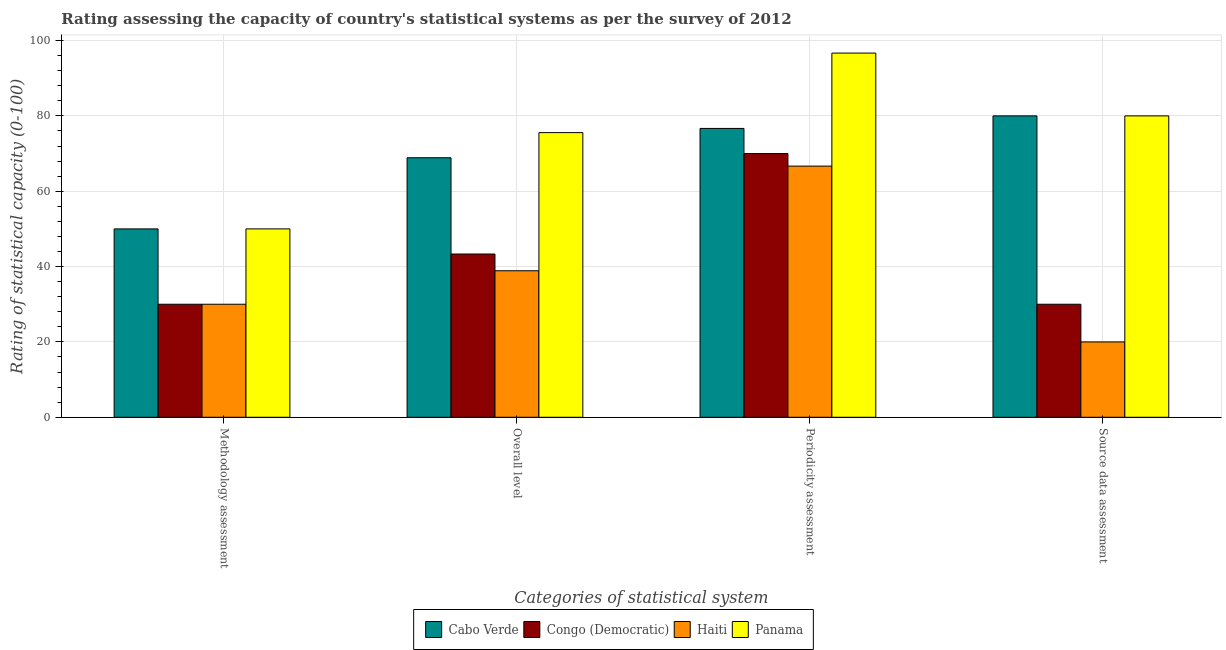How many different coloured bars are there?
Your answer should be compact. 4. How many bars are there on the 4th tick from the left?
Ensure brevity in your answer.  4. What is the label of the 1st group of bars from the left?
Make the answer very short. Methodology assessment. What is the methodology assessment rating in Cabo Verde?
Your answer should be compact. 50. Across all countries, what is the maximum periodicity assessment rating?
Provide a succinct answer. 96.67. Across all countries, what is the minimum periodicity assessment rating?
Keep it short and to the point. 66.67. In which country was the methodology assessment rating maximum?
Make the answer very short. Cabo Verde. In which country was the methodology assessment rating minimum?
Offer a very short reply. Congo (Democratic). What is the total source data assessment rating in the graph?
Keep it short and to the point. 210. What is the difference between the methodology assessment rating in Haiti and that in Congo (Democratic)?
Make the answer very short. 0. What is the difference between the source data assessment rating in Haiti and the periodicity assessment rating in Cabo Verde?
Make the answer very short. -56.67. What is the average overall level rating per country?
Offer a very short reply. 56.67. What is the difference between the source data assessment rating and overall level rating in Congo (Democratic)?
Offer a terse response. -13.33. What is the difference between the highest and the second highest periodicity assessment rating?
Give a very brief answer. 20. What is the difference between the highest and the lowest source data assessment rating?
Provide a succinct answer. 60. Is the sum of the periodicity assessment rating in Congo (Democratic) and Panama greater than the maximum overall level rating across all countries?
Your response must be concise. Yes. What does the 3rd bar from the left in Overall level represents?
Your answer should be compact. Haiti. What does the 3rd bar from the right in Methodology assessment represents?
Make the answer very short. Congo (Democratic). How many bars are there?
Provide a succinct answer. 16. What is the difference between two consecutive major ticks on the Y-axis?
Make the answer very short. 20. Are the values on the major ticks of Y-axis written in scientific E-notation?
Offer a very short reply. No. Where does the legend appear in the graph?
Provide a short and direct response. Bottom center. How are the legend labels stacked?
Keep it short and to the point. Horizontal. What is the title of the graph?
Your answer should be very brief. Rating assessing the capacity of country's statistical systems as per the survey of 2012 . What is the label or title of the X-axis?
Give a very brief answer. Categories of statistical system. What is the label or title of the Y-axis?
Offer a very short reply. Rating of statistical capacity (0-100). What is the Rating of statistical capacity (0-100) in Congo (Democratic) in Methodology assessment?
Your answer should be compact. 30. What is the Rating of statistical capacity (0-100) of Panama in Methodology assessment?
Your response must be concise. 50. What is the Rating of statistical capacity (0-100) in Cabo Verde in Overall level?
Give a very brief answer. 68.89. What is the Rating of statistical capacity (0-100) in Congo (Democratic) in Overall level?
Your answer should be compact. 43.33. What is the Rating of statistical capacity (0-100) of Haiti in Overall level?
Give a very brief answer. 38.89. What is the Rating of statistical capacity (0-100) of Panama in Overall level?
Ensure brevity in your answer.  75.56. What is the Rating of statistical capacity (0-100) of Cabo Verde in Periodicity assessment?
Your answer should be compact. 76.67. What is the Rating of statistical capacity (0-100) of Haiti in Periodicity assessment?
Make the answer very short. 66.67. What is the Rating of statistical capacity (0-100) in Panama in Periodicity assessment?
Offer a very short reply. 96.67. Across all Categories of statistical system, what is the maximum Rating of statistical capacity (0-100) in Cabo Verde?
Make the answer very short. 80. Across all Categories of statistical system, what is the maximum Rating of statistical capacity (0-100) in Congo (Democratic)?
Ensure brevity in your answer.  70. Across all Categories of statistical system, what is the maximum Rating of statistical capacity (0-100) in Haiti?
Provide a short and direct response. 66.67. Across all Categories of statistical system, what is the maximum Rating of statistical capacity (0-100) in Panama?
Your answer should be compact. 96.67. Across all Categories of statistical system, what is the minimum Rating of statistical capacity (0-100) of Panama?
Ensure brevity in your answer.  50. What is the total Rating of statistical capacity (0-100) in Cabo Verde in the graph?
Offer a very short reply. 275.56. What is the total Rating of statistical capacity (0-100) in Congo (Democratic) in the graph?
Your response must be concise. 173.33. What is the total Rating of statistical capacity (0-100) in Haiti in the graph?
Provide a short and direct response. 155.56. What is the total Rating of statistical capacity (0-100) in Panama in the graph?
Ensure brevity in your answer.  302.22. What is the difference between the Rating of statistical capacity (0-100) in Cabo Verde in Methodology assessment and that in Overall level?
Make the answer very short. -18.89. What is the difference between the Rating of statistical capacity (0-100) of Congo (Democratic) in Methodology assessment and that in Overall level?
Provide a short and direct response. -13.33. What is the difference between the Rating of statistical capacity (0-100) in Haiti in Methodology assessment and that in Overall level?
Your answer should be very brief. -8.89. What is the difference between the Rating of statistical capacity (0-100) in Panama in Methodology assessment and that in Overall level?
Offer a terse response. -25.56. What is the difference between the Rating of statistical capacity (0-100) of Cabo Verde in Methodology assessment and that in Periodicity assessment?
Offer a very short reply. -26.67. What is the difference between the Rating of statistical capacity (0-100) of Haiti in Methodology assessment and that in Periodicity assessment?
Your answer should be very brief. -36.67. What is the difference between the Rating of statistical capacity (0-100) of Panama in Methodology assessment and that in Periodicity assessment?
Your response must be concise. -46.67. What is the difference between the Rating of statistical capacity (0-100) of Cabo Verde in Methodology assessment and that in Source data assessment?
Offer a terse response. -30. What is the difference between the Rating of statistical capacity (0-100) in Congo (Democratic) in Methodology assessment and that in Source data assessment?
Your answer should be compact. 0. What is the difference between the Rating of statistical capacity (0-100) in Cabo Verde in Overall level and that in Periodicity assessment?
Offer a terse response. -7.78. What is the difference between the Rating of statistical capacity (0-100) of Congo (Democratic) in Overall level and that in Periodicity assessment?
Make the answer very short. -26.67. What is the difference between the Rating of statistical capacity (0-100) in Haiti in Overall level and that in Periodicity assessment?
Keep it short and to the point. -27.78. What is the difference between the Rating of statistical capacity (0-100) in Panama in Overall level and that in Periodicity assessment?
Offer a terse response. -21.11. What is the difference between the Rating of statistical capacity (0-100) of Cabo Verde in Overall level and that in Source data assessment?
Give a very brief answer. -11.11. What is the difference between the Rating of statistical capacity (0-100) in Congo (Democratic) in Overall level and that in Source data assessment?
Make the answer very short. 13.33. What is the difference between the Rating of statistical capacity (0-100) in Haiti in Overall level and that in Source data assessment?
Your answer should be very brief. 18.89. What is the difference between the Rating of statistical capacity (0-100) in Panama in Overall level and that in Source data assessment?
Provide a succinct answer. -4.44. What is the difference between the Rating of statistical capacity (0-100) of Cabo Verde in Periodicity assessment and that in Source data assessment?
Make the answer very short. -3.33. What is the difference between the Rating of statistical capacity (0-100) of Haiti in Periodicity assessment and that in Source data assessment?
Provide a short and direct response. 46.67. What is the difference between the Rating of statistical capacity (0-100) in Panama in Periodicity assessment and that in Source data assessment?
Offer a very short reply. 16.67. What is the difference between the Rating of statistical capacity (0-100) in Cabo Verde in Methodology assessment and the Rating of statistical capacity (0-100) in Haiti in Overall level?
Ensure brevity in your answer.  11.11. What is the difference between the Rating of statistical capacity (0-100) of Cabo Verde in Methodology assessment and the Rating of statistical capacity (0-100) of Panama in Overall level?
Offer a very short reply. -25.56. What is the difference between the Rating of statistical capacity (0-100) of Congo (Democratic) in Methodology assessment and the Rating of statistical capacity (0-100) of Haiti in Overall level?
Offer a terse response. -8.89. What is the difference between the Rating of statistical capacity (0-100) in Congo (Democratic) in Methodology assessment and the Rating of statistical capacity (0-100) in Panama in Overall level?
Provide a succinct answer. -45.56. What is the difference between the Rating of statistical capacity (0-100) in Haiti in Methodology assessment and the Rating of statistical capacity (0-100) in Panama in Overall level?
Offer a terse response. -45.56. What is the difference between the Rating of statistical capacity (0-100) in Cabo Verde in Methodology assessment and the Rating of statistical capacity (0-100) in Haiti in Periodicity assessment?
Your answer should be compact. -16.67. What is the difference between the Rating of statistical capacity (0-100) in Cabo Verde in Methodology assessment and the Rating of statistical capacity (0-100) in Panama in Periodicity assessment?
Keep it short and to the point. -46.67. What is the difference between the Rating of statistical capacity (0-100) of Congo (Democratic) in Methodology assessment and the Rating of statistical capacity (0-100) of Haiti in Periodicity assessment?
Keep it short and to the point. -36.67. What is the difference between the Rating of statistical capacity (0-100) of Congo (Democratic) in Methodology assessment and the Rating of statistical capacity (0-100) of Panama in Periodicity assessment?
Provide a short and direct response. -66.67. What is the difference between the Rating of statistical capacity (0-100) in Haiti in Methodology assessment and the Rating of statistical capacity (0-100) in Panama in Periodicity assessment?
Ensure brevity in your answer.  -66.67. What is the difference between the Rating of statistical capacity (0-100) of Cabo Verde in Methodology assessment and the Rating of statistical capacity (0-100) of Congo (Democratic) in Source data assessment?
Keep it short and to the point. 20. What is the difference between the Rating of statistical capacity (0-100) of Cabo Verde in Overall level and the Rating of statistical capacity (0-100) of Congo (Democratic) in Periodicity assessment?
Offer a terse response. -1.11. What is the difference between the Rating of statistical capacity (0-100) of Cabo Verde in Overall level and the Rating of statistical capacity (0-100) of Haiti in Periodicity assessment?
Ensure brevity in your answer.  2.22. What is the difference between the Rating of statistical capacity (0-100) of Cabo Verde in Overall level and the Rating of statistical capacity (0-100) of Panama in Periodicity assessment?
Give a very brief answer. -27.78. What is the difference between the Rating of statistical capacity (0-100) in Congo (Democratic) in Overall level and the Rating of statistical capacity (0-100) in Haiti in Periodicity assessment?
Give a very brief answer. -23.33. What is the difference between the Rating of statistical capacity (0-100) of Congo (Democratic) in Overall level and the Rating of statistical capacity (0-100) of Panama in Periodicity assessment?
Make the answer very short. -53.33. What is the difference between the Rating of statistical capacity (0-100) in Haiti in Overall level and the Rating of statistical capacity (0-100) in Panama in Periodicity assessment?
Keep it short and to the point. -57.78. What is the difference between the Rating of statistical capacity (0-100) in Cabo Verde in Overall level and the Rating of statistical capacity (0-100) in Congo (Democratic) in Source data assessment?
Your response must be concise. 38.89. What is the difference between the Rating of statistical capacity (0-100) in Cabo Verde in Overall level and the Rating of statistical capacity (0-100) in Haiti in Source data assessment?
Your answer should be very brief. 48.89. What is the difference between the Rating of statistical capacity (0-100) in Cabo Verde in Overall level and the Rating of statistical capacity (0-100) in Panama in Source data assessment?
Give a very brief answer. -11.11. What is the difference between the Rating of statistical capacity (0-100) of Congo (Democratic) in Overall level and the Rating of statistical capacity (0-100) of Haiti in Source data assessment?
Offer a terse response. 23.33. What is the difference between the Rating of statistical capacity (0-100) of Congo (Democratic) in Overall level and the Rating of statistical capacity (0-100) of Panama in Source data assessment?
Your answer should be very brief. -36.67. What is the difference between the Rating of statistical capacity (0-100) of Haiti in Overall level and the Rating of statistical capacity (0-100) of Panama in Source data assessment?
Your answer should be very brief. -41.11. What is the difference between the Rating of statistical capacity (0-100) in Cabo Verde in Periodicity assessment and the Rating of statistical capacity (0-100) in Congo (Democratic) in Source data assessment?
Your answer should be very brief. 46.67. What is the difference between the Rating of statistical capacity (0-100) in Cabo Verde in Periodicity assessment and the Rating of statistical capacity (0-100) in Haiti in Source data assessment?
Ensure brevity in your answer.  56.67. What is the difference between the Rating of statistical capacity (0-100) in Congo (Democratic) in Periodicity assessment and the Rating of statistical capacity (0-100) in Haiti in Source data assessment?
Your response must be concise. 50. What is the difference between the Rating of statistical capacity (0-100) in Haiti in Periodicity assessment and the Rating of statistical capacity (0-100) in Panama in Source data assessment?
Give a very brief answer. -13.33. What is the average Rating of statistical capacity (0-100) in Cabo Verde per Categories of statistical system?
Offer a terse response. 68.89. What is the average Rating of statistical capacity (0-100) of Congo (Democratic) per Categories of statistical system?
Provide a succinct answer. 43.33. What is the average Rating of statistical capacity (0-100) of Haiti per Categories of statistical system?
Offer a very short reply. 38.89. What is the average Rating of statistical capacity (0-100) in Panama per Categories of statistical system?
Give a very brief answer. 75.56. What is the difference between the Rating of statistical capacity (0-100) in Cabo Verde and Rating of statistical capacity (0-100) in Panama in Methodology assessment?
Your answer should be very brief. 0. What is the difference between the Rating of statistical capacity (0-100) of Congo (Democratic) and Rating of statistical capacity (0-100) of Haiti in Methodology assessment?
Provide a succinct answer. 0. What is the difference between the Rating of statistical capacity (0-100) in Congo (Democratic) and Rating of statistical capacity (0-100) in Panama in Methodology assessment?
Your answer should be very brief. -20. What is the difference between the Rating of statistical capacity (0-100) in Haiti and Rating of statistical capacity (0-100) in Panama in Methodology assessment?
Offer a very short reply. -20. What is the difference between the Rating of statistical capacity (0-100) in Cabo Verde and Rating of statistical capacity (0-100) in Congo (Democratic) in Overall level?
Keep it short and to the point. 25.56. What is the difference between the Rating of statistical capacity (0-100) in Cabo Verde and Rating of statistical capacity (0-100) in Panama in Overall level?
Your answer should be very brief. -6.67. What is the difference between the Rating of statistical capacity (0-100) in Congo (Democratic) and Rating of statistical capacity (0-100) in Haiti in Overall level?
Give a very brief answer. 4.44. What is the difference between the Rating of statistical capacity (0-100) in Congo (Democratic) and Rating of statistical capacity (0-100) in Panama in Overall level?
Provide a short and direct response. -32.22. What is the difference between the Rating of statistical capacity (0-100) in Haiti and Rating of statistical capacity (0-100) in Panama in Overall level?
Your answer should be very brief. -36.67. What is the difference between the Rating of statistical capacity (0-100) in Cabo Verde and Rating of statistical capacity (0-100) in Congo (Democratic) in Periodicity assessment?
Provide a succinct answer. 6.67. What is the difference between the Rating of statistical capacity (0-100) of Cabo Verde and Rating of statistical capacity (0-100) of Panama in Periodicity assessment?
Give a very brief answer. -20. What is the difference between the Rating of statistical capacity (0-100) of Congo (Democratic) and Rating of statistical capacity (0-100) of Haiti in Periodicity assessment?
Provide a succinct answer. 3.33. What is the difference between the Rating of statistical capacity (0-100) of Congo (Democratic) and Rating of statistical capacity (0-100) of Panama in Periodicity assessment?
Provide a short and direct response. -26.67. What is the difference between the Rating of statistical capacity (0-100) in Haiti and Rating of statistical capacity (0-100) in Panama in Periodicity assessment?
Your response must be concise. -30. What is the difference between the Rating of statistical capacity (0-100) in Cabo Verde and Rating of statistical capacity (0-100) in Congo (Democratic) in Source data assessment?
Your answer should be very brief. 50. What is the difference between the Rating of statistical capacity (0-100) in Cabo Verde and Rating of statistical capacity (0-100) in Haiti in Source data assessment?
Give a very brief answer. 60. What is the difference between the Rating of statistical capacity (0-100) of Cabo Verde and Rating of statistical capacity (0-100) of Panama in Source data assessment?
Give a very brief answer. 0. What is the difference between the Rating of statistical capacity (0-100) in Congo (Democratic) and Rating of statistical capacity (0-100) in Panama in Source data assessment?
Ensure brevity in your answer.  -50. What is the difference between the Rating of statistical capacity (0-100) in Haiti and Rating of statistical capacity (0-100) in Panama in Source data assessment?
Give a very brief answer. -60. What is the ratio of the Rating of statistical capacity (0-100) in Cabo Verde in Methodology assessment to that in Overall level?
Ensure brevity in your answer.  0.73. What is the ratio of the Rating of statistical capacity (0-100) of Congo (Democratic) in Methodology assessment to that in Overall level?
Keep it short and to the point. 0.69. What is the ratio of the Rating of statistical capacity (0-100) in Haiti in Methodology assessment to that in Overall level?
Ensure brevity in your answer.  0.77. What is the ratio of the Rating of statistical capacity (0-100) in Panama in Methodology assessment to that in Overall level?
Provide a short and direct response. 0.66. What is the ratio of the Rating of statistical capacity (0-100) in Cabo Verde in Methodology assessment to that in Periodicity assessment?
Your answer should be compact. 0.65. What is the ratio of the Rating of statistical capacity (0-100) of Congo (Democratic) in Methodology assessment to that in Periodicity assessment?
Ensure brevity in your answer.  0.43. What is the ratio of the Rating of statistical capacity (0-100) in Haiti in Methodology assessment to that in Periodicity assessment?
Give a very brief answer. 0.45. What is the ratio of the Rating of statistical capacity (0-100) in Panama in Methodology assessment to that in Periodicity assessment?
Give a very brief answer. 0.52. What is the ratio of the Rating of statistical capacity (0-100) in Cabo Verde in Methodology assessment to that in Source data assessment?
Keep it short and to the point. 0.62. What is the ratio of the Rating of statistical capacity (0-100) of Congo (Democratic) in Methodology assessment to that in Source data assessment?
Provide a succinct answer. 1. What is the ratio of the Rating of statistical capacity (0-100) of Haiti in Methodology assessment to that in Source data assessment?
Keep it short and to the point. 1.5. What is the ratio of the Rating of statistical capacity (0-100) in Cabo Verde in Overall level to that in Periodicity assessment?
Provide a short and direct response. 0.9. What is the ratio of the Rating of statistical capacity (0-100) in Congo (Democratic) in Overall level to that in Periodicity assessment?
Offer a terse response. 0.62. What is the ratio of the Rating of statistical capacity (0-100) in Haiti in Overall level to that in Periodicity assessment?
Your response must be concise. 0.58. What is the ratio of the Rating of statistical capacity (0-100) of Panama in Overall level to that in Periodicity assessment?
Ensure brevity in your answer.  0.78. What is the ratio of the Rating of statistical capacity (0-100) of Cabo Verde in Overall level to that in Source data assessment?
Keep it short and to the point. 0.86. What is the ratio of the Rating of statistical capacity (0-100) in Congo (Democratic) in Overall level to that in Source data assessment?
Provide a succinct answer. 1.44. What is the ratio of the Rating of statistical capacity (0-100) of Haiti in Overall level to that in Source data assessment?
Provide a short and direct response. 1.94. What is the ratio of the Rating of statistical capacity (0-100) of Panama in Overall level to that in Source data assessment?
Make the answer very short. 0.94. What is the ratio of the Rating of statistical capacity (0-100) of Congo (Democratic) in Periodicity assessment to that in Source data assessment?
Provide a succinct answer. 2.33. What is the ratio of the Rating of statistical capacity (0-100) of Haiti in Periodicity assessment to that in Source data assessment?
Offer a very short reply. 3.33. What is the ratio of the Rating of statistical capacity (0-100) of Panama in Periodicity assessment to that in Source data assessment?
Keep it short and to the point. 1.21. What is the difference between the highest and the second highest Rating of statistical capacity (0-100) of Congo (Democratic)?
Make the answer very short. 26.67. What is the difference between the highest and the second highest Rating of statistical capacity (0-100) of Haiti?
Make the answer very short. 27.78. What is the difference between the highest and the second highest Rating of statistical capacity (0-100) of Panama?
Give a very brief answer. 16.67. What is the difference between the highest and the lowest Rating of statistical capacity (0-100) in Cabo Verde?
Offer a very short reply. 30. What is the difference between the highest and the lowest Rating of statistical capacity (0-100) in Congo (Democratic)?
Your answer should be compact. 40. What is the difference between the highest and the lowest Rating of statistical capacity (0-100) of Haiti?
Your response must be concise. 46.67. What is the difference between the highest and the lowest Rating of statistical capacity (0-100) in Panama?
Offer a very short reply. 46.67. 